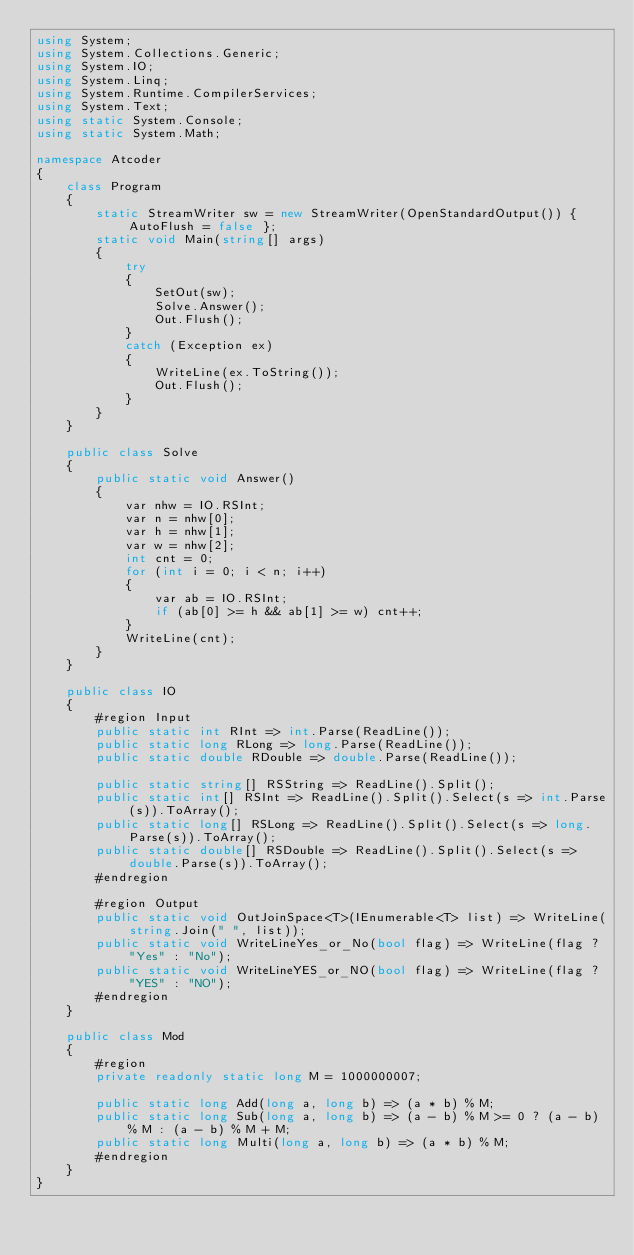<code> <loc_0><loc_0><loc_500><loc_500><_C#_>using System;
using System.Collections.Generic;
using System.IO;
using System.Linq;
using System.Runtime.CompilerServices;
using System.Text;
using static System.Console;
using static System.Math;

namespace Atcoder
{
    class Program
    {
        static StreamWriter sw = new StreamWriter(OpenStandardOutput()) { AutoFlush = false };
        static void Main(string[] args)
        {
            try
            {
                SetOut(sw);
                Solve.Answer();
                Out.Flush();
            }
            catch (Exception ex)
            {
                WriteLine(ex.ToString());
                Out.Flush();
            }
        }
    }

    public class Solve
    {
        public static void Answer()
        {
            var nhw = IO.RSInt;
            var n = nhw[0];
            var h = nhw[1];
            var w = nhw[2];
            int cnt = 0;
            for (int i = 0; i < n; i++)
            {
                var ab = IO.RSInt;
                if (ab[0] >= h && ab[1] >= w) cnt++;
            }
            WriteLine(cnt);
        }
    }

    public class IO
    {
        #region Input
        public static int RInt => int.Parse(ReadLine());
        public static long RLong => long.Parse(ReadLine());
        public static double RDouble => double.Parse(ReadLine());

        public static string[] RSString => ReadLine().Split();
        public static int[] RSInt => ReadLine().Split().Select(s => int.Parse(s)).ToArray();
        public static long[] RSLong => ReadLine().Split().Select(s => long.Parse(s)).ToArray();
        public static double[] RSDouble => ReadLine().Split().Select(s => double.Parse(s)).ToArray();
        #endregion

        #region Output
        public static void OutJoinSpace<T>(IEnumerable<T> list) => WriteLine(string.Join(" ", list));
        public static void WriteLineYes_or_No(bool flag) => WriteLine(flag ? "Yes" : "No");
        public static void WriteLineYES_or_NO(bool flag) => WriteLine(flag ? "YES" : "NO");
        #endregion
    }

    public class Mod
    {
        #region
        private readonly static long M = 1000000007;

        public static long Add(long a, long b) => (a * b) % M;
        public static long Sub(long a, long b) => (a - b) % M >= 0 ? (a - b) % M : (a - b) % M + M;
        public static long Multi(long a, long b) => (a * b) % M;
        #endregion
    }
}</code> 